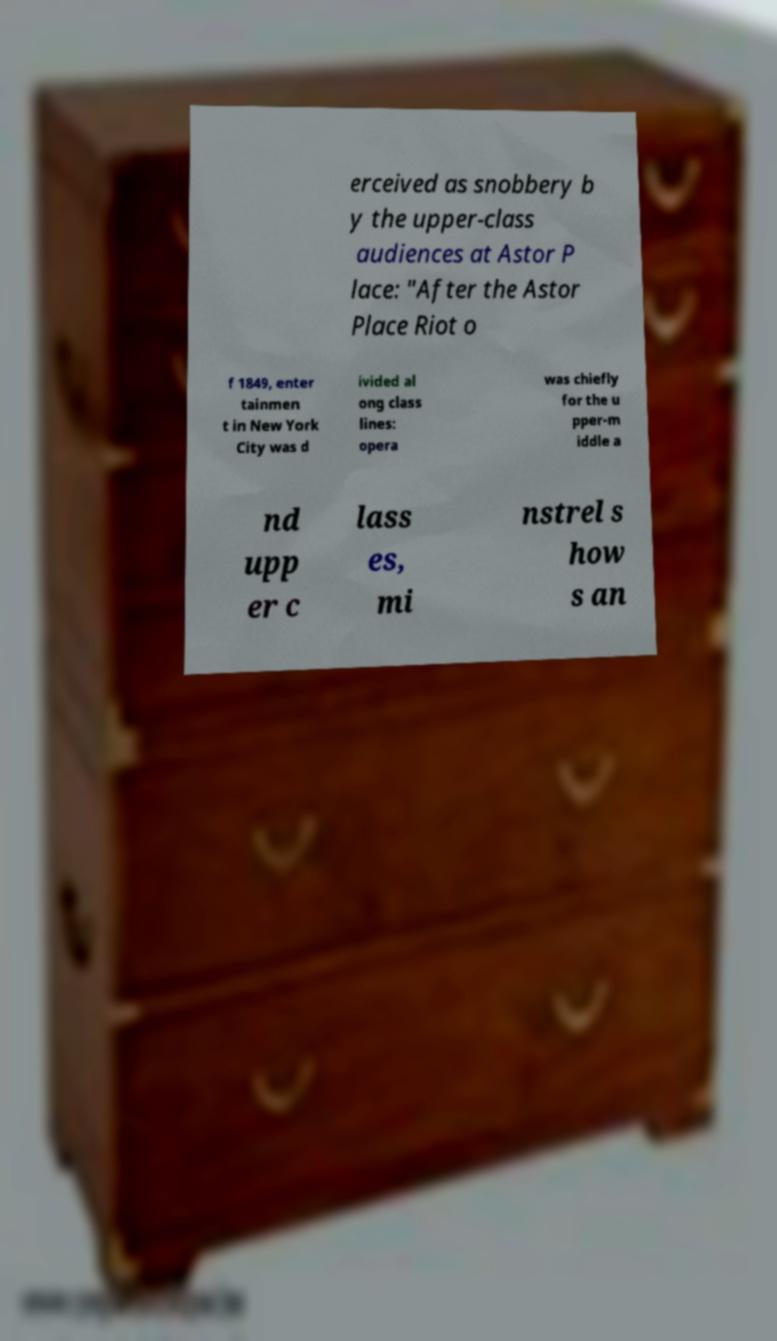There's text embedded in this image that I need extracted. Can you transcribe it verbatim? erceived as snobbery b y the upper-class audiences at Astor P lace: "After the Astor Place Riot o f 1849, enter tainmen t in New York City was d ivided al ong class lines: opera was chiefly for the u pper-m iddle a nd upp er c lass es, mi nstrel s how s an 